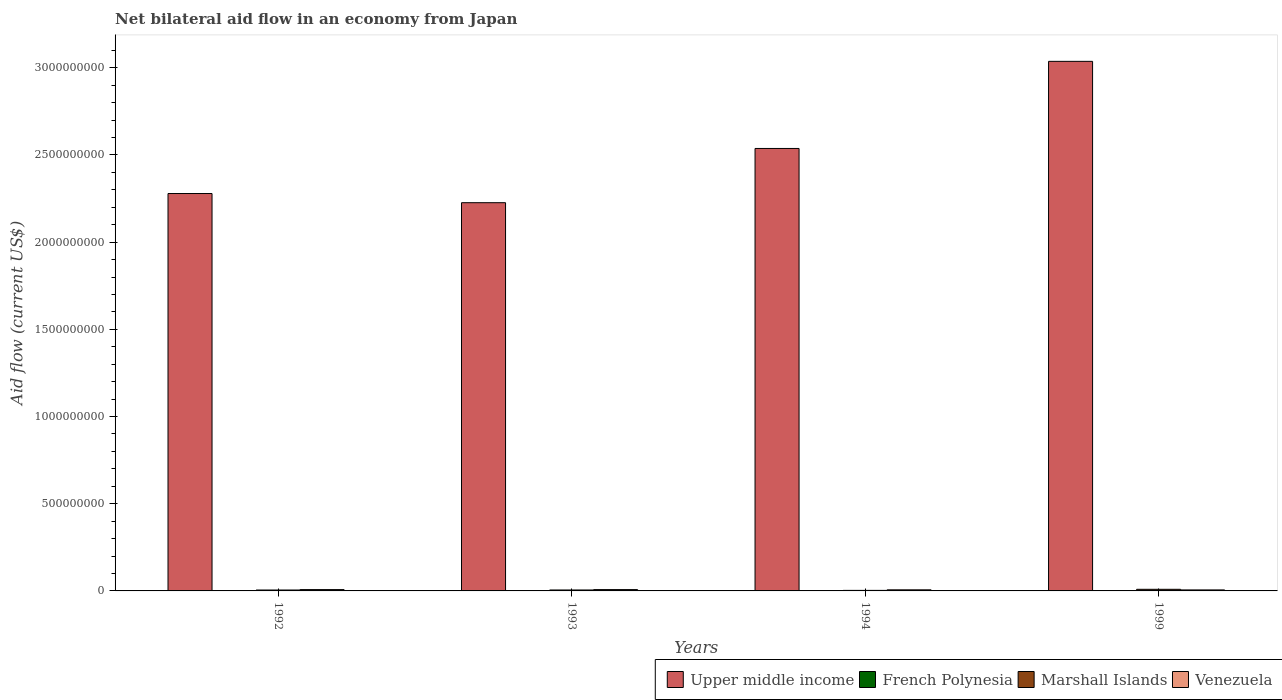Are the number of bars on each tick of the X-axis equal?
Your answer should be compact. Yes. In how many cases, is the number of bars for a given year not equal to the number of legend labels?
Ensure brevity in your answer.  0. What is the net bilateral aid flow in Upper middle income in 1993?
Ensure brevity in your answer.  2.23e+09. Across all years, what is the minimum net bilateral aid flow in Marshall Islands?
Ensure brevity in your answer.  3.05e+06. What is the total net bilateral aid flow in Upper middle income in the graph?
Your answer should be very brief. 1.01e+1. What is the difference between the net bilateral aid flow in Marshall Islands in 1992 and that in 1999?
Provide a short and direct response. -3.96e+06. What is the difference between the net bilateral aid flow in Upper middle income in 1993 and the net bilateral aid flow in Venezuela in 1994?
Provide a short and direct response. 2.22e+09. What is the average net bilateral aid flow in French Polynesia per year?
Your response must be concise. 9.50e+04. In the year 1999, what is the difference between the net bilateral aid flow in French Polynesia and net bilateral aid flow in Upper middle income?
Ensure brevity in your answer.  -3.04e+09. What is the ratio of the net bilateral aid flow in Marshall Islands in 1993 to that in 1999?
Your answer should be compact. 0.58. Is the net bilateral aid flow in Venezuela in 1992 less than that in 1993?
Provide a short and direct response. No. Is the difference between the net bilateral aid flow in French Polynesia in 1994 and 1999 greater than the difference between the net bilateral aid flow in Upper middle income in 1994 and 1999?
Provide a succinct answer. Yes. What is the difference between the highest and the lowest net bilateral aid flow in Upper middle income?
Your answer should be compact. 8.11e+08. In how many years, is the net bilateral aid flow in Marshall Islands greater than the average net bilateral aid flow in Marshall Islands taken over all years?
Give a very brief answer. 1. Is the sum of the net bilateral aid flow in Marshall Islands in 1992 and 1994 greater than the maximum net bilateral aid flow in French Polynesia across all years?
Offer a very short reply. Yes. What does the 2nd bar from the left in 1999 represents?
Your answer should be very brief. French Polynesia. What does the 2nd bar from the right in 1999 represents?
Ensure brevity in your answer.  Marshall Islands. Is it the case that in every year, the sum of the net bilateral aid flow in Upper middle income and net bilateral aid flow in French Polynesia is greater than the net bilateral aid flow in Venezuela?
Keep it short and to the point. Yes. How many bars are there?
Ensure brevity in your answer.  16. Are all the bars in the graph horizontal?
Keep it short and to the point. No. How many years are there in the graph?
Provide a short and direct response. 4. What is the difference between two consecutive major ticks on the Y-axis?
Provide a succinct answer. 5.00e+08. Are the values on the major ticks of Y-axis written in scientific E-notation?
Provide a succinct answer. No. Does the graph contain any zero values?
Give a very brief answer. No. Does the graph contain grids?
Your response must be concise. No. How many legend labels are there?
Your answer should be very brief. 4. How are the legend labels stacked?
Provide a succinct answer. Horizontal. What is the title of the graph?
Provide a short and direct response. Net bilateral aid flow in an economy from Japan. Does "Puerto Rico" appear as one of the legend labels in the graph?
Provide a short and direct response. No. What is the label or title of the Y-axis?
Provide a short and direct response. Aid flow (current US$). What is the Aid flow (current US$) of Upper middle income in 1992?
Keep it short and to the point. 2.28e+09. What is the Aid flow (current US$) in Marshall Islands in 1992?
Provide a succinct answer. 5.27e+06. What is the Aid flow (current US$) of Venezuela in 1992?
Offer a very short reply. 7.69e+06. What is the Aid flow (current US$) of Upper middle income in 1993?
Keep it short and to the point. 2.23e+09. What is the Aid flow (current US$) in French Polynesia in 1993?
Provide a short and direct response. 1.40e+05. What is the Aid flow (current US$) of Marshall Islands in 1993?
Provide a succinct answer. 5.39e+06. What is the Aid flow (current US$) in Venezuela in 1993?
Your response must be concise. 7.67e+06. What is the Aid flow (current US$) in Upper middle income in 1994?
Provide a short and direct response. 2.54e+09. What is the Aid flow (current US$) of French Polynesia in 1994?
Offer a terse response. 6.00e+04. What is the Aid flow (current US$) of Marshall Islands in 1994?
Provide a short and direct response. 3.05e+06. What is the Aid flow (current US$) in Venezuela in 1994?
Your answer should be compact. 6.30e+06. What is the Aid flow (current US$) in Upper middle income in 1999?
Provide a succinct answer. 3.04e+09. What is the Aid flow (current US$) of French Polynesia in 1999?
Make the answer very short. 10000. What is the Aid flow (current US$) in Marshall Islands in 1999?
Keep it short and to the point. 9.23e+06. What is the Aid flow (current US$) in Venezuela in 1999?
Your answer should be compact. 5.79e+06. Across all years, what is the maximum Aid flow (current US$) in Upper middle income?
Ensure brevity in your answer.  3.04e+09. Across all years, what is the maximum Aid flow (current US$) in Marshall Islands?
Your response must be concise. 9.23e+06. Across all years, what is the maximum Aid flow (current US$) in Venezuela?
Provide a succinct answer. 7.69e+06. Across all years, what is the minimum Aid flow (current US$) in Upper middle income?
Make the answer very short. 2.23e+09. Across all years, what is the minimum Aid flow (current US$) of Marshall Islands?
Provide a short and direct response. 3.05e+06. Across all years, what is the minimum Aid flow (current US$) of Venezuela?
Make the answer very short. 5.79e+06. What is the total Aid flow (current US$) of Upper middle income in the graph?
Your response must be concise. 1.01e+1. What is the total Aid flow (current US$) of French Polynesia in the graph?
Your response must be concise. 3.80e+05. What is the total Aid flow (current US$) of Marshall Islands in the graph?
Your answer should be compact. 2.29e+07. What is the total Aid flow (current US$) of Venezuela in the graph?
Your answer should be very brief. 2.74e+07. What is the difference between the Aid flow (current US$) of Upper middle income in 1992 and that in 1993?
Provide a succinct answer. 5.26e+07. What is the difference between the Aid flow (current US$) of Venezuela in 1992 and that in 1993?
Provide a short and direct response. 2.00e+04. What is the difference between the Aid flow (current US$) of Upper middle income in 1992 and that in 1994?
Provide a short and direct response. -2.58e+08. What is the difference between the Aid flow (current US$) in Marshall Islands in 1992 and that in 1994?
Offer a terse response. 2.22e+06. What is the difference between the Aid flow (current US$) in Venezuela in 1992 and that in 1994?
Your answer should be very brief. 1.39e+06. What is the difference between the Aid flow (current US$) in Upper middle income in 1992 and that in 1999?
Your response must be concise. -7.58e+08. What is the difference between the Aid flow (current US$) of Marshall Islands in 1992 and that in 1999?
Your answer should be very brief. -3.96e+06. What is the difference between the Aid flow (current US$) of Venezuela in 1992 and that in 1999?
Your response must be concise. 1.90e+06. What is the difference between the Aid flow (current US$) of Upper middle income in 1993 and that in 1994?
Keep it short and to the point. -3.11e+08. What is the difference between the Aid flow (current US$) in Marshall Islands in 1993 and that in 1994?
Make the answer very short. 2.34e+06. What is the difference between the Aid flow (current US$) in Venezuela in 1993 and that in 1994?
Keep it short and to the point. 1.37e+06. What is the difference between the Aid flow (current US$) of Upper middle income in 1993 and that in 1999?
Ensure brevity in your answer.  -8.11e+08. What is the difference between the Aid flow (current US$) in Marshall Islands in 1993 and that in 1999?
Provide a succinct answer. -3.84e+06. What is the difference between the Aid flow (current US$) of Venezuela in 1993 and that in 1999?
Your response must be concise. 1.88e+06. What is the difference between the Aid flow (current US$) of Upper middle income in 1994 and that in 1999?
Give a very brief answer. -5.00e+08. What is the difference between the Aid flow (current US$) in French Polynesia in 1994 and that in 1999?
Make the answer very short. 5.00e+04. What is the difference between the Aid flow (current US$) in Marshall Islands in 1994 and that in 1999?
Your answer should be very brief. -6.18e+06. What is the difference between the Aid flow (current US$) of Venezuela in 1994 and that in 1999?
Your response must be concise. 5.10e+05. What is the difference between the Aid flow (current US$) of Upper middle income in 1992 and the Aid flow (current US$) of French Polynesia in 1993?
Provide a succinct answer. 2.28e+09. What is the difference between the Aid flow (current US$) of Upper middle income in 1992 and the Aid flow (current US$) of Marshall Islands in 1993?
Your answer should be compact. 2.27e+09. What is the difference between the Aid flow (current US$) of Upper middle income in 1992 and the Aid flow (current US$) of Venezuela in 1993?
Your answer should be very brief. 2.27e+09. What is the difference between the Aid flow (current US$) in French Polynesia in 1992 and the Aid flow (current US$) in Marshall Islands in 1993?
Your answer should be very brief. -5.22e+06. What is the difference between the Aid flow (current US$) of French Polynesia in 1992 and the Aid flow (current US$) of Venezuela in 1993?
Your answer should be very brief. -7.50e+06. What is the difference between the Aid flow (current US$) of Marshall Islands in 1992 and the Aid flow (current US$) of Venezuela in 1993?
Give a very brief answer. -2.40e+06. What is the difference between the Aid flow (current US$) in Upper middle income in 1992 and the Aid flow (current US$) in French Polynesia in 1994?
Keep it short and to the point. 2.28e+09. What is the difference between the Aid flow (current US$) of Upper middle income in 1992 and the Aid flow (current US$) of Marshall Islands in 1994?
Ensure brevity in your answer.  2.28e+09. What is the difference between the Aid flow (current US$) of Upper middle income in 1992 and the Aid flow (current US$) of Venezuela in 1994?
Provide a succinct answer. 2.27e+09. What is the difference between the Aid flow (current US$) of French Polynesia in 1992 and the Aid flow (current US$) of Marshall Islands in 1994?
Provide a short and direct response. -2.88e+06. What is the difference between the Aid flow (current US$) in French Polynesia in 1992 and the Aid flow (current US$) in Venezuela in 1994?
Ensure brevity in your answer.  -6.13e+06. What is the difference between the Aid flow (current US$) in Marshall Islands in 1992 and the Aid flow (current US$) in Venezuela in 1994?
Keep it short and to the point. -1.03e+06. What is the difference between the Aid flow (current US$) of Upper middle income in 1992 and the Aid flow (current US$) of French Polynesia in 1999?
Provide a succinct answer. 2.28e+09. What is the difference between the Aid flow (current US$) in Upper middle income in 1992 and the Aid flow (current US$) in Marshall Islands in 1999?
Provide a short and direct response. 2.27e+09. What is the difference between the Aid flow (current US$) of Upper middle income in 1992 and the Aid flow (current US$) of Venezuela in 1999?
Offer a very short reply. 2.27e+09. What is the difference between the Aid flow (current US$) of French Polynesia in 1992 and the Aid flow (current US$) of Marshall Islands in 1999?
Give a very brief answer. -9.06e+06. What is the difference between the Aid flow (current US$) in French Polynesia in 1992 and the Aid flow (current US$) in Venezuela in 1999?
Your answer should be compact. -5.62e+06. What is the difference between the Aid flow (current US$) of Marshall Islands in 1992 and the Aid flow (current US$) of Venezuela in 1999?
Your answer should be compact. -5.20e+05. What is the difference between the Aid flow (current US$) of Upper middle income in 1993 and the Aid flow (current US$) of French Polynesia in 1994?
Offer a terse response. 2.23e+09. What is the difference between the Aid flow (current US$) in Upper middle income in 1993 and the Aid flow (current US$) in Marshall Islands in 1994?
Your response must be concise. 2.22e+09. What is the difference between the Aid flow (current US$) of Upper middle income in 1993 and the Aid flow (current US$) of Venezuela in 1994?
Provide a short and direct response. 2.22e+09. What is the difference between the Aid flow (current US$) in French Polynesia in 1993 and the Aid flow (current US$) in Marshall Islands in 1994?
Your answer should be compact. -2.91e+06. What is the difference between the Aid flow (current US$) of French Polynesia in 1993 and the Aid flow (current US$) of Venezuela in 1994?
Your response must be concise. -6.16e+06. What is the difference between the Aid flow (current US$) of Marshall Islands in 1993 and the Aid flow (current US$) of Venezuela in 1994?
Make the answer very short. -9.10e+05. What is the difference between the Aid flow (current US$) in Upper middle income in 1993 and the Aid flow (current US$) in French Polynesia in 1999?
Offer a very short reply. 2.23e+09. What is the difference between the Aid flow (current US$) in Upper middle income in 1993 and the Aid flow (current US$) in Marshall Islands in 1999?
Your response must be concise. 2.22e+09. What is the difference between the Aid flow (current US$) in Upper middle income in 1993 and the Aid flow (current US$) in Venezuela in 1999?
Ensure brevity in your answer.  2.22e+09. What is the difference between the Aid flow (current US$) of French Polynesia in 1993 and the Aid flow (current US$) of Marshall Islands in 1999?
Ensure brevity in your answer.  -9.09e+06. What is the difference between the Aid flow (current US$) in French Polynesia in 1993 and the Aid flow (current US$) in Venezuela in 1999?
Your answer should be compact. -5.65e+06. What is the difference between the Aid flow (current US$) in Marshall Islands in 1993 and the Aid flow (current US$) in Venezuela in 1999?
Make the answer very short. -4.00e+05. What is the difference between the Aid flow (current US$) in Upper middle income in 1994 and the Aid flow (current US$) in French Polynesia in 1999?
Ensure brevity in your answer.  2.54e+09. What is the difference between the Aid flow (current US$) of Upper middle income in 1994 and the Aid flow (current US$) of Marshall Islands in 1999?
Ensure brevity in your answer.  2.53e+09. What is the difference between the Aid flow (current US$) in Upper middle income in 1994 and the Aid flow (current US$) in Venezuela in 1999?
Provide a succinct answer. 2.53e+09. What is the difference between the Aid flow (current US$) in French Polynesia in 1994 and the Aid flow (current US$) in Marshall Islands in 1999?
Your answer should be very brief. -9.17e+06. What is the difference between the Aid flow (current US$) in French Polynesia in 1994 and the Aid flow (current US$) in Venezuela in 1999?
Provide a short and direct response. -5.73e+06. What is the difference between the Aid flow (current US$) of Marshall Islands in 1994 and the Aid flow (current US$) of Venezuela in 1999?
Your answer should be compact. -2.74e+06. What is the average Aid flow (current US$) of Upper middle income per year?
Your answer should be compact. 2.52e+09. What is the average Aid flow (current US$) in French Polynesia per year?
Keep it short and to the point. 9.50e+04. What is the average Aid flow (current US$) in Marshall Islands per year?
Provide a short and direct response. 5.74e+06. What is the average Aid flow (current US$) in Venezuela per year?
Your answer should be compact. 6.86e+06. In the year 1992, what is the difference between the Aid flow (current US$) of Upper middle income and Aid flow (current US$) of French Polynesia?
Your response must be concise. 2.28e+09. In the year 1992, what is the difference between the Aid flow (current US$) in Upper middle income and Aid flow (current US$) in Marshall Islands?
Provide a short and direct response. 2.27e+09. In the year 1992, what is the difference between the Aid flow (current US$) in Upper middle income and Aid flow (current US$) in Venezuela?
Provide a succinct answer. 2.27e+09. In the year 1992, what is the difference between the Aid flow (current US$) of French Polynesia and Aid flow (current US$) of Marshall Islands?
Your response must be concise. -5.10e+06. In the year 1992, what is the difference between the Aid flow (current US$) of French Polynesia and Aid flow (current US$) of Venezuela?
Your answer should be compact. -7.52e+06. In the year 1992, what is the difference between the Aid flow (current US$) of Marshall Islands and Aid flow (current US$) of Venezuela?
Give a very brief answer. -2.42e+06. In the year 1993, what is the difference between the Aid flow (current US$) in Upper middle income and Aid flow (current US$) in French Polynesia?
Your response must be concise. 2.23e+09. In the year 1993, what is the difference between the Aid flow (current US$) in Upper middle income and Aid flow (current US$) in Marshall Islands?
Keep it short and to the point. 2.22e+09. In the year 1993, what is the difference between the Aid flow (current US$) of Upper middle income and Aid flow (current US$) of Venezuela?
Provide a succinct answer. 2.22e+09. In the year 1993, what is the difference between the Aid flow (current US$) in French Polynesia and Aid flow (current US$) in Marshall Islands?
Your response must be concise. -5.25e+06. In the year 1993, what is the difference between the Aid flow (current US$) in French Polynesia and Aid flow (current US$) in Venezuela?
Your answer should be compact. -7.53e+06. In the year 1993, what is the difference between the Aid flow (current US$) in Marshall Islands and Aid flow (current US$) in Venezuela?
Keep it short and to the point. -2.28e+06. In the year 1994, what is the difference between the Aid flow (current US$) of Upper middle income and Aid flow (current US$) of French Polynesia?
Provide a short and direct response. 2.54e+09. In the year 1994, what is the difference between the Aid flow (current US$) in Upper middle income and Aid flow (current US$) in Marshall Islands?
Offer a very short reply. 2.53e+09. In the year 1994, what is the difference between the Aid flow (current US$) in Upper middle income and Aid flow (current US$) in Venezuela?
Your answer should be very brief. 2.53e+09. In the year 1994, what is the difference between the Aid flow (current US$) in French Polynesia and Aid flow (current US$) in Marshall Islands?
Provide a succinct answer. -2.99e+06. In the year 1994, what is the difference between the Aid flow (current US$) of French Polynesia and Aid flow (current US$) of Venezuela?
Give a very brief answer. -6.24e+06. In the year 1994, what is the difference between the Aid flow (current US$) of Marshall Islands and Aid flow (current US$) of Venezuela?
Offer a terse response. -3.25e+06. In the year 1999, what is the difference between the Aid flow (current US$) in Upper middle income and Aid flow (current US$) in French Polynesia?
Provide a succinct answer. 3.04e+09. In the year 1999, what is the difference between the Aid flow (current US$) of Upper middle income and Aid flow (current US$) of Marshall Islands?
Give a very brief answer. 3.03e+09. In the year 1999, what is the difference between the Aid flow (current US$) in Upper middle income and Aid flow (current US$) in Venezuela?
Your answer should be compact. 3.03e+09. In the year 1999, what is the difference between the Aid flow (current US$) in French Polynesia and Aid flow (current US$) in Marshall Islands?
Provide a succinct answer. -9.22e+06. In the year 1999, what is the difference between the Aid flow (current US$) in French Polynesia and Aid flow (current US$) in Venezuela?
Offer a very short reply. -5.78e+06. In the year 1999, what is the difference between the Aid flow (current US$) of Marshall Islands and Aid flow (current US$) of Venezuela?
Keep it short and to the point. 3.44e+06. What is the ratio of the Aid flow (current US$) of Upper middle income in 1992 to that in 1993?
Make the answer very short. 1.02. What is the ratio of the Aid flow (current US$) in French Polynesia in 1992 to that in 1993?
Keep it short and to the point. 1.21. What is the ratio of the Aid flow (current US$) of Marshall Islands in 1992 to that in 1993?
Give a very brief answer. 0.98. What is the ratio of the Aid flow (current US$) of Venezuela in 1992 to that in 1993?
Your response must be concise. 1. What is the ratio of the Aid flow (current US$) in Upper middle income in 1992 to that in 1994?
Your answer should be very brief. 0.9. What is the ratio of the Aid flow (current US$) of French Polynesia in 1992 to that in 1994?
Provide a succinct answer. 2.83. What is the ratio of the Aid flow (current US$) of Marshall Islands in 1992 to that in 1994?
Offer a terse response. 1.73. What is the ratio of the Aid flow (current US$) of Venezuela in 1992 to that in 1994?
Ensure brevity in your answer.  1.22. What is the ratio of the Aid flow (current US$) of Upper middle income in 1992 to that in 1999?
Give a very brief answer. 0.75. What is the ratio of the Aid flow (current US$) in French Polynesia in 1992 to that in 1999?
Make the answer very short. 17. What is the ratio of the Aid flow (current US$) in Marshall Islands in 1992 to that in 1999?
Your response must be concise. 0.57. What is the ratio of the Aid flow (current US$) in Venezuela in 1992 to that in 1999?
Ensure brevity in your answer.  1.33. What is the ratio of the Aid flow (current US$) in Upper middle income in 1993 to that in 1994?
Your answer should be very brief. 0.88. What is the ratio of the Aid flow (current US$) in French Polynesia in 1993 to that in 1994?
Give a very brief answer. 2.33. What is the ratio of the Aid flow (current US$) of Marshall Islands in 1993 to that in 1994?
Your answer should be compact. 1.77. What is the ratio of the Aid flow (current US$) of Venezuela in 1993 to that in 1994?
Provide a short and direct response. 1.22. What is the ratio of the Aid flow (current US$) of Upper middle income in 1993 to that in 1999?
Offer a terse response. 0.73. What is the ratio of the Aid flow (current US$) of French Polynesia in 1993 to that in 1999?
Offer a terse response. 14. What is the ratio of the Aid flow (current US$) in Marshall Islands in 1993 to that in 1999?
Ensure brevity in your answer.  0.58. What is the ratio of the Aid flow (current US$) in Venezuela in 1993 to that in 1999?
Your answer should be compact. 1.32. What is the ratio of the Aid flow (current US$) of Upper middle income in 1994 to that in 1999?
Provide a short and direct response. 0.84. What is the ratio of the Aid flow (current US$) of French Polynesia in 1994 to that in 1999?
Offer a terse response. 6. What is the ratio of the Aid flow (current US$) in Marshall Islands in 1994 to that in 1999?
Keep it short and to the point. 0.33. What is the ratio of the Aid flow (current US$) in Venezuela in 1994 to that in 1999?
Your answer should be compact. 1.09. What is the difference between the highest and the second highest Aid flow (current US$) of Upper middle income?
Provide a short and direct response. 5.00e+08. What is the difference between the highest and the second highest Aid flow (current US$) in Marshall Islands?
Give a very brief answer. 3.84e+06. What is the difference between the highest and the lowest Aid flow (current US$) in Upper middle income?
Offer a terse response. 8.11e+08. What is the difference between the highest and the lowest Aid flow (current US$) in Marshall Islands?
Give a very brief answer. 6.18e+06. What is the difference between the highest and the lowest Aid flow (current US$) in Venezuela?
Ensure brevity in your answer.  1.90e+06. 